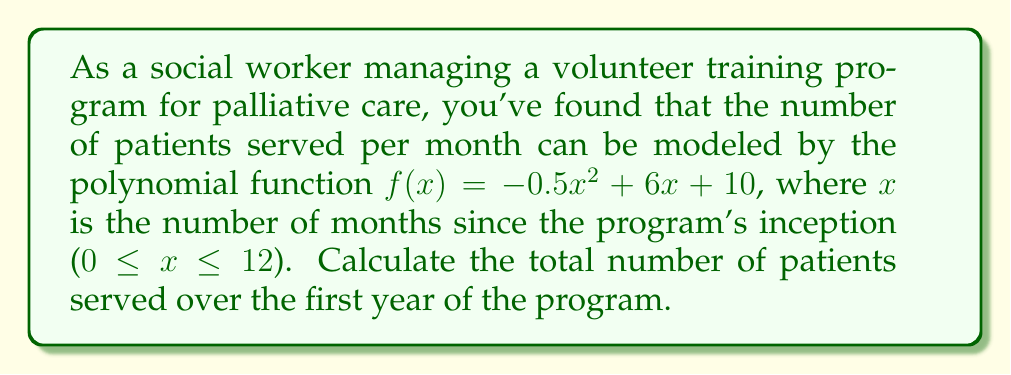Can you answer this question? To find the total number of patients served over the first year, we need to calculate the area under the curve of $f(x)$ from $x = 0$ to $x = 12$. This can be done using definite integration.

1) The function is $f(x) = -0.5x^2 + 6x + 10$

2) We need to integrate this function from 0 to 12:

   $$\int_0^{12} (-0.5x^2 + 6x + 10) dx$$

3) Integrate each term:
   $$\left[-\frac{1}{6}x^3 + 3x^2 + 10x\right]_0^{12}$$

4) Evaluate at the upper and lower bounds:
   $$\left(-\frac{1}{6}(12)^3 + 3(12)^2 + 10(12)\right) - \left(-\frac{1}{6}(0)^3 + 3(0)^2 + 10(0)\right)$$

5) Simplify:
   $$(-288 + 432 + 120) - (0)$$
   $$= 264$$

Therefore, the total number of patients served over the first year is 264.
Answer: 264 patients 